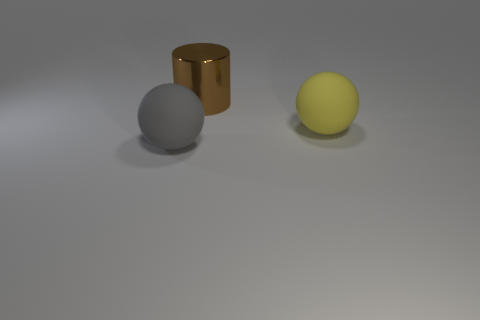What textures are visible on the surfaces of these objects? The objects have smooth surfaces with the cylinder showing a reflective texture that mirrors its surroundings, while the spheres have a matte finish with no reflections. 